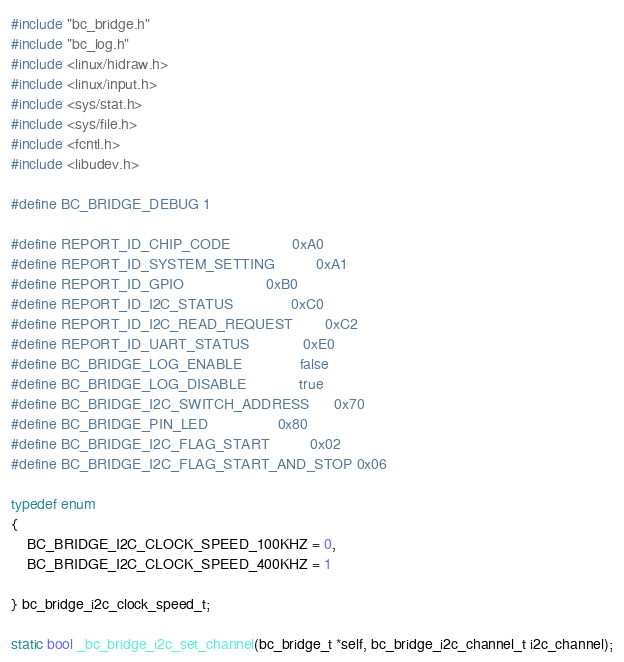Convert code to text. <code><loc_0><loc_0><loc_500><loc_500><_C_>#include "bc_bridge.h"
#include "bc_log.h"
#include <linux/hidraw.h>
#include <linux/input.h>
#include <sys/stat.h>
#include <sys/file.h>
#include <fcntl.h>
#include <libudev.h>

#define BC_BRIDGE_DEBUG 1

#define REPORT_ID_CHIP_CODE               0xA0
#define REPORT_ID_SYSTEM_SETTING          0xA1
#define REPORT_ID_GPIO                    0xB0
#define REPORT_ID_I2C_STATUS              0xC0
#define REPORT_ID_I2C_READ_REQUEST        0xC2
#define REPORT_ID_UART_STATUS             0xE0
#define BC_BRIDGE_LOG_ENABLE              false
#define BC_BRIDGE_LOG_DISABLE             true
#define BC_BRIDGE_I2C_SWITCH_ADDRESS      0x70
#define BC_BRIDGE_PIN_LED                 0x80
#define BC_BRIDGE_I2C_FLAG_START          0x02
#define BC_BRIDGE_I2C_FLAG_START_AND_STOP 0x06

typedef enum
{
    BC_BRIDGE_I2C_CLOCK_SPEED_100KHZ = 0,
    BC_BRIDGE_I2C_CLOCK_SPEED_400KHZ = 1

} bc_bridge_i2c_clock_speed_t;

static bool _bc_bridge_i2c_set_channel(bc_bridge_t *self, bc_bridge_i2c_channel_t i2c_channel);</code> 